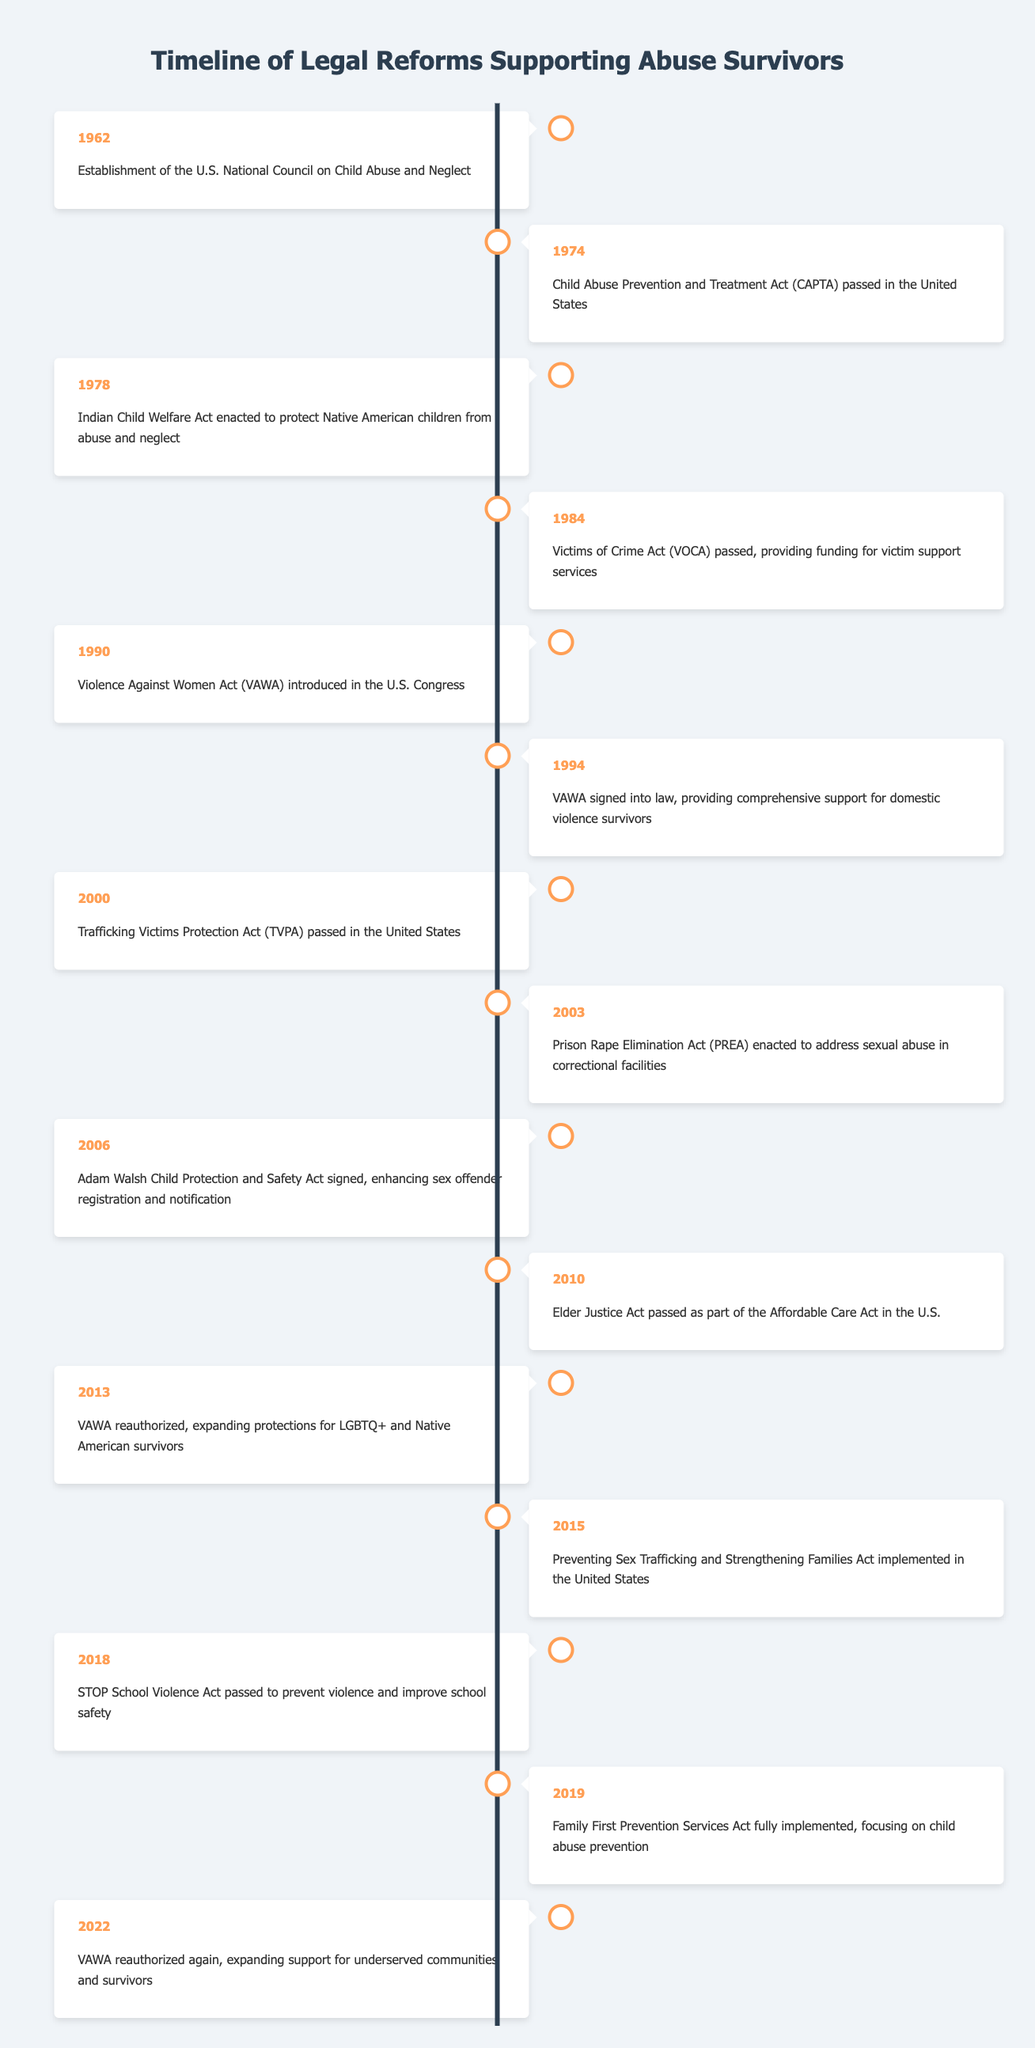What year was the Victims of Crime Act passed? The table shows that the Victims of Crime Act (VOCA) was passed in the year 1984.
Answer: 1984 What significant act was signed into law in 1994? According to the table, the Violence Against Women Act (VAWA) was signed into law in 1994, providing comprehensive support for domestic violence survivors.
Answer: Violence Against Women Act (VAWA) How many years passed between the establishment of the National Council on Child Abuse and the signing of the Violence Against Women Act? The National Council on Child Abuse was established in 1962 and VAWA was signed in 1994. Calculating the difference, 1994 - 1962 equals 32 years.
Answer: 32 years Was the Elder Justice Act passed before or after the Trafficking Victims Protection Act? The table indicates that the Trafficking Victims Protection Act (TVPA) was passed in 2000 and the Elder Justice Act in 2010. Thus, the Elder Justice Act was passed after the TVPA.
Answer: After Which event occurred in 2013 and what was its significance? The table indicates that in 2013, the Violence Against Women Act (VAWA) was reauthorized, expanding protections for LGBTQ+ and Native American survivors. This signifies a commitment to inclusiveness in survivor protections.
Answer: VAWA reauthorized, expanding protections for LGBTQ+ and Native American survivors What is the average year of the events listed in the table? The years in the table are 1962, 1974, 1978, 1984, 1990, 1994, 2000, 2003, 2006, 2010, 2013, 2015, 2018, 2019, and 2022. The sum of these years is 19858. There are 15 events, so the average year is 19858/15, approximately 1970.53. The average year falls in the early 1970s, specifically about 1971.
Answer: Approximately 1971 How many major legal reforms were implemented between 2000 and 2010? From the table, we see that the Trafficking Victims Protection Act (2000), Prison Rape Elimination Act (2003), Adam Walsh Child Protection and Safety Act (2006), and Elder Justice Act (2010) represent 4 significant legal reforms implemented between these years.
Answer: 4 reforms Did the Family First Prevention Services Act focus on prevention or punitive measures? The description in the table states that the Family First Prevention Services Act focused on child abuse prevention, indicating a preventive approach rather than punitive measures.
Answer: Preventive approach Which two acts were specifically aimed at different age groups and what were they? The table lists the Elder Justice Act (2010), focusing on elder abuse prevention, and the Adam Walsh Child Protection and Safety Act (2006), aimed at child protection. Both target distinct age groups: elders and children.
Answer: Elder Justice Act and Adam Walsh Child Protection and Safety Act 